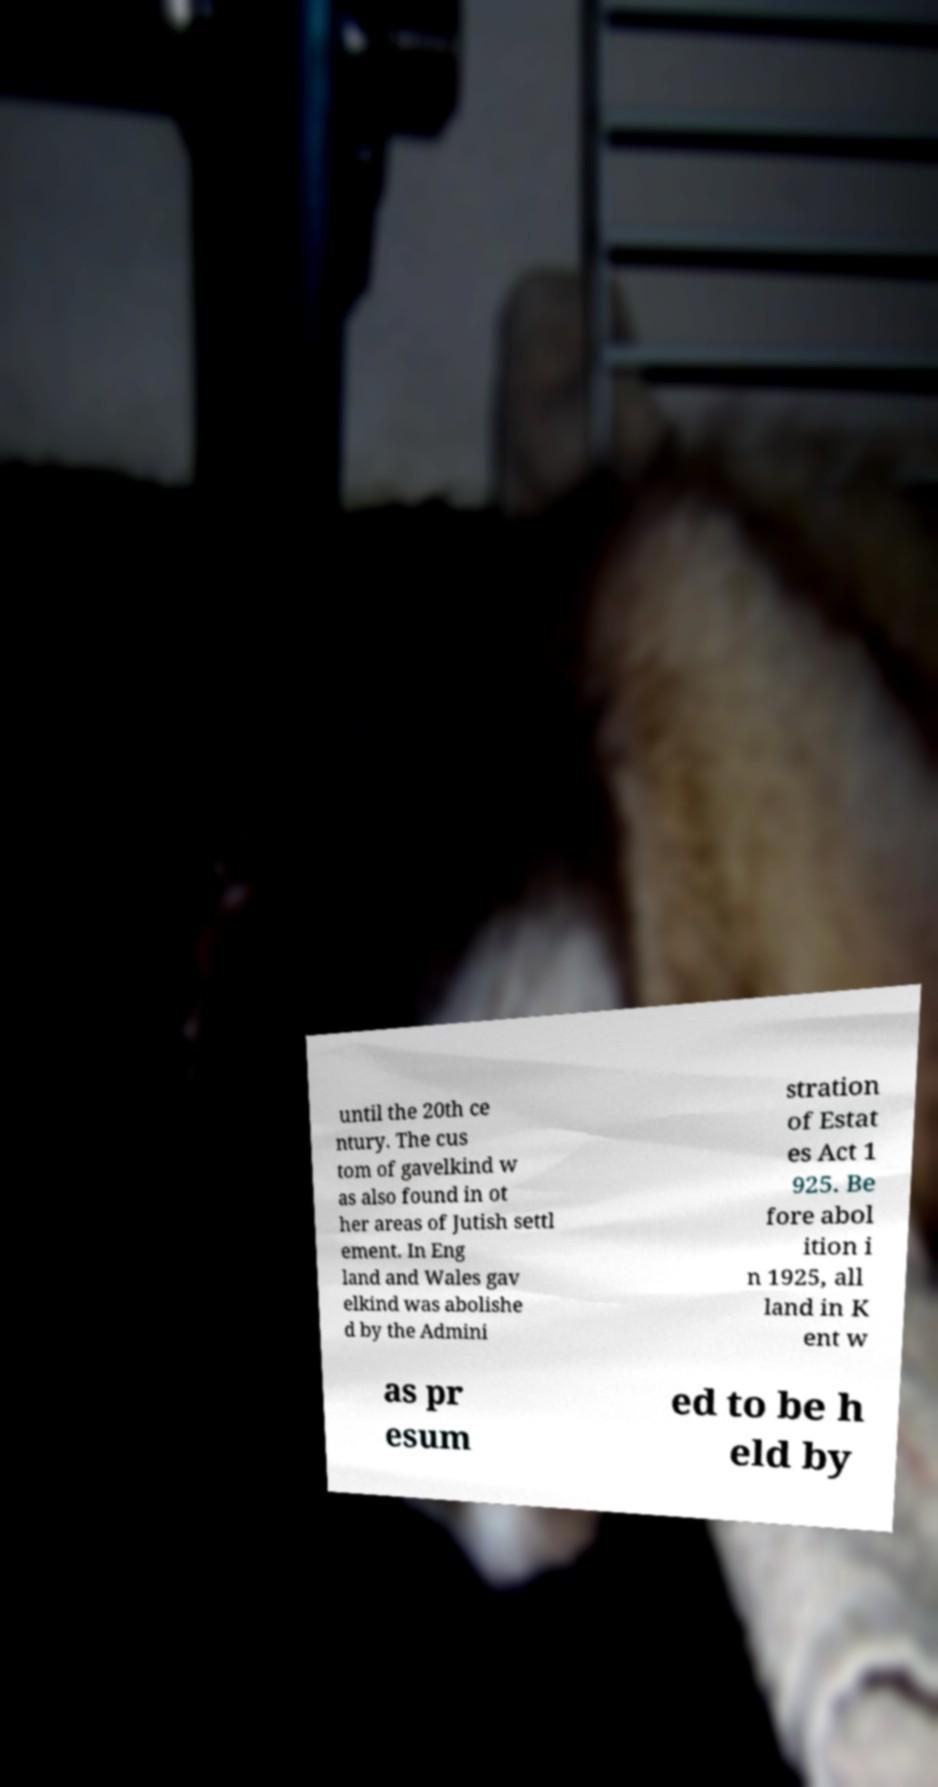Please identify and transcribe the text found in this image. until the 20th ce ntury. The cus tom of gavelkind w as also found in ot her areas of Jutish settl ement. In Eng land and Wales gav elkind was abolishe d by the Admini stration of Estat es Act 1 925. Be fore abol ition i n 1925, all land in K ent w as pr esum ed to be h eld by 